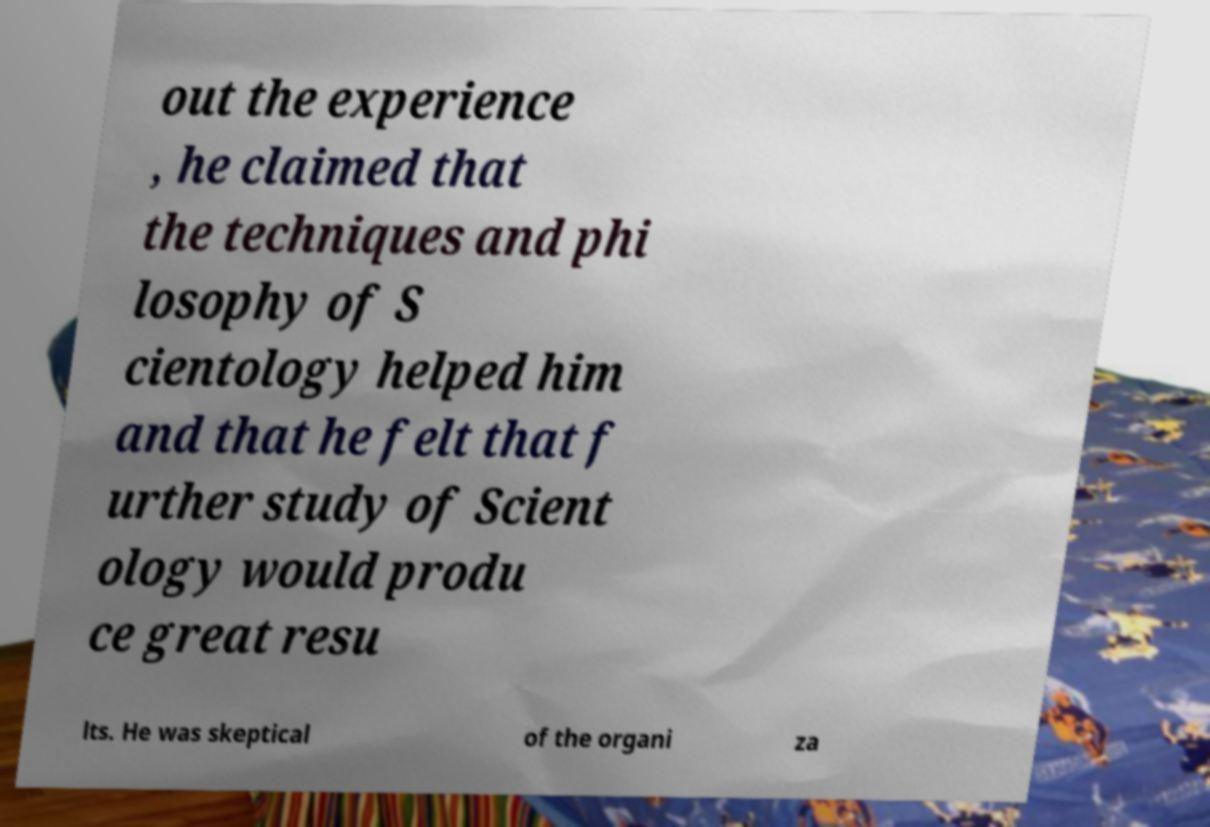Could you assist in decoding the text presented in this image and type it out clearly? out the experience , he claimed that the techniques and phi losophy of S cientology helped him and that he felt that f urther study of Scient ology would produ ce great resu lts. He was skeptical of the organi za 